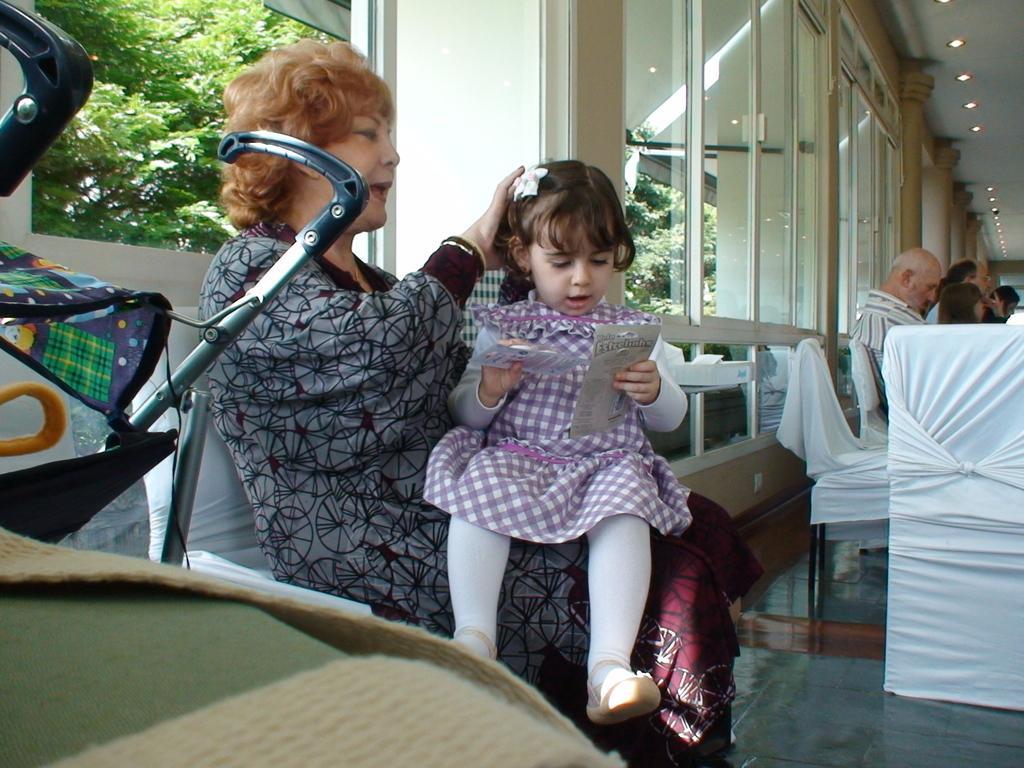Could you give a brief overview of what you see in this image? In the foreground of this image, there is a little girl sitting on the woman. On the left side of the image, there is a baby cart. In the background, there are persons sitting on the chair and few windows. 